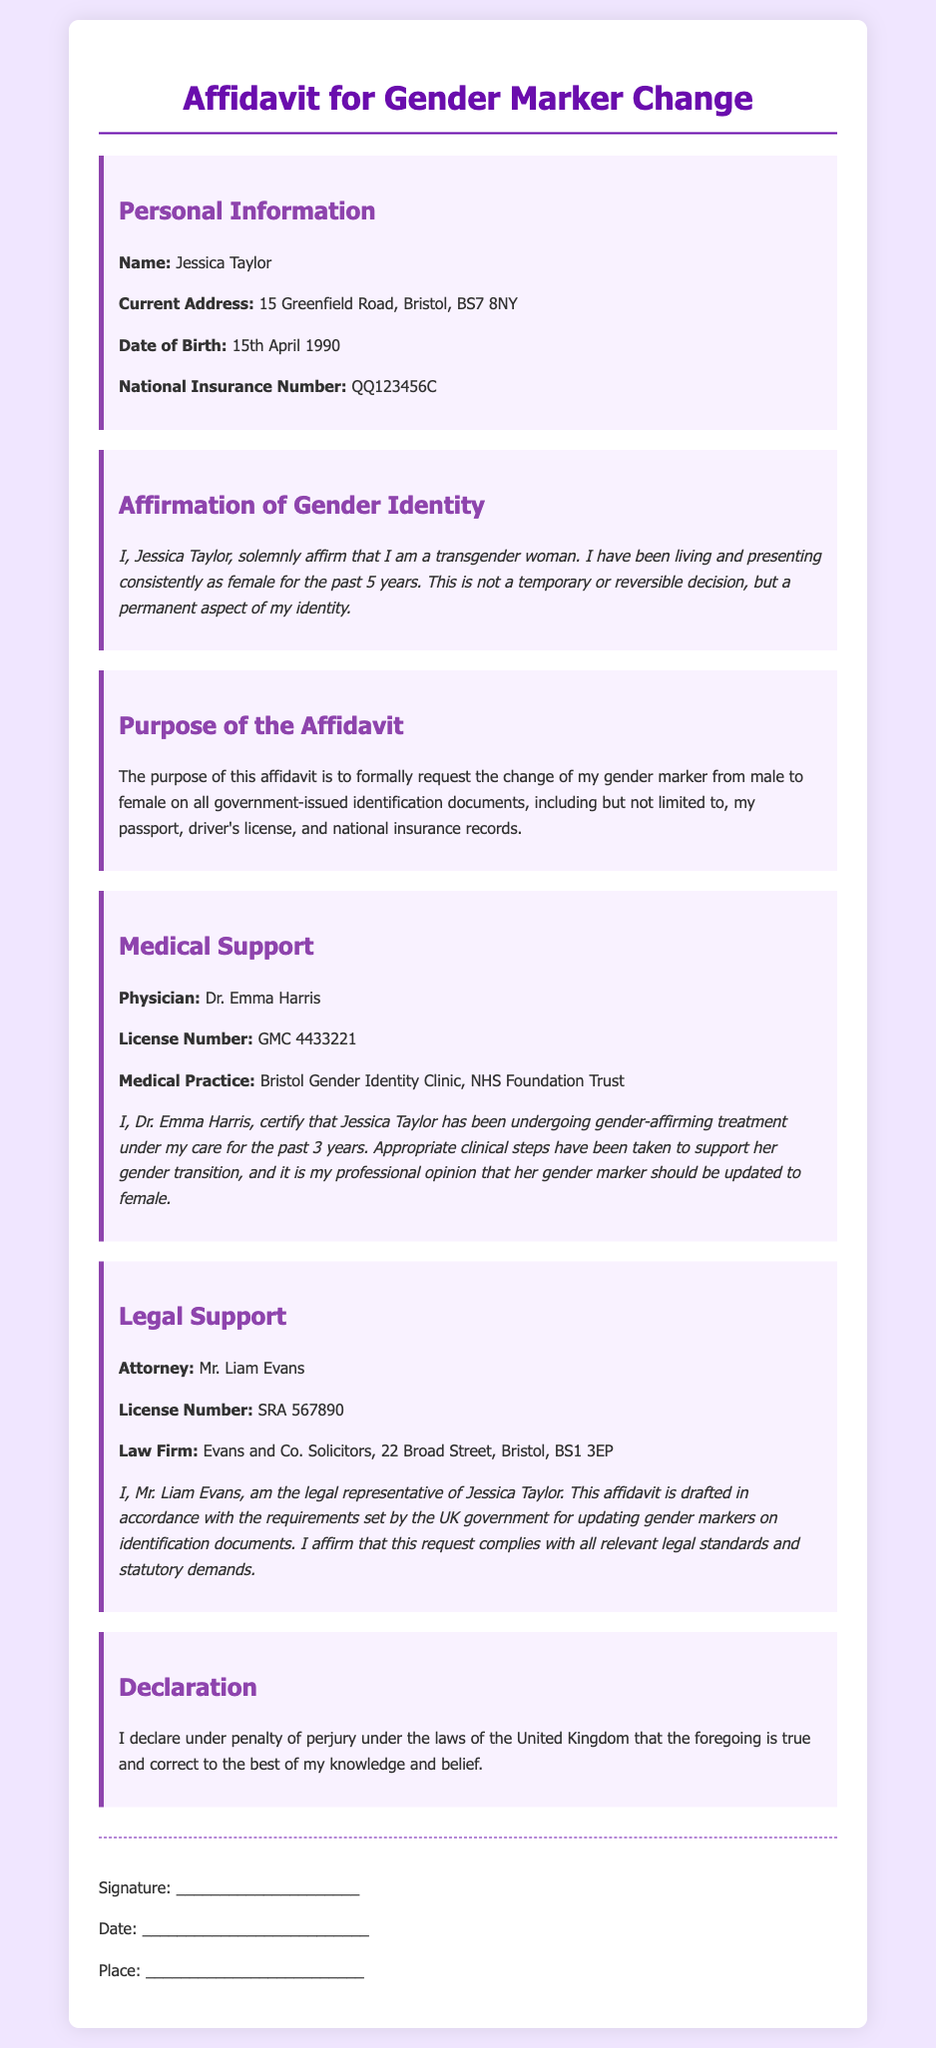What is the full name of the individual in the affidavit? The document states that the individual's name is Jessica Taylor.
Answer: Jessica Taylor What is the current address of Jessica Taylor? The current address provided in the affidavit is 15 Greenfield Road, Bristol, BS7 8NY.
Answer: 15 Greenfield Road, Bristol, BS7 8NY What is the date of birth of Jessica Taylor? The affidavit specifies that Jessica Taylor's date of birth is 15th April 1990.
Answer: 15th April 1990 Who is the physician certifying the medical support? The document mentions Dr. Emma Harris as the physician providing medical support.
Answer: Dr. Emma Harris How many years has Jessica Taylor been undergoing gender-affirming treatment? The affidavit states that Jessica Taylor has been undergoing treatment for the past 3 years.
Answer: 3 years What is the purpose of this affidavit? The purpose is to formally request the change of the gender marker from male to female on government identification documents.
Answer: Change of gender marker Who is the legal representative mentioned in the document? Mr. Liam Evans is identified as the legal representative of Jessica Taylor in the affidavit.
Answer: Mr. Liam Evans What type of document is this affidavit intended to support? The affidavit is intended to support the updating of gender markers on identification documents.
Answer: Identification documents What does Jessica Taylor declare under penalty of? Jessica Taylor declares under penalty of perjury under the laws of the United Kingdom.
Answer: Perjury 